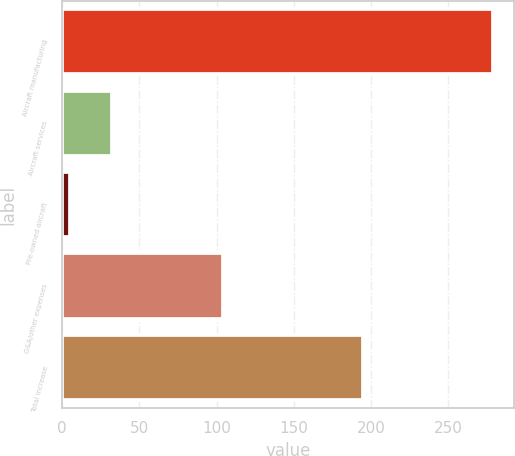Convert chart to OTSL. <chart><loc_0><loc_0><loc_500><loc_500><bar_chart><fcel>Aircraft manufacturing<fcel>Aircraft services<fcel>Pre-owned aircraft<fcel>G&A/other expenses<fcel>Total increase<nl><fcel>279<fcel>32.4<fcel>5<fcel>104<fcel>195<nl></chart> 